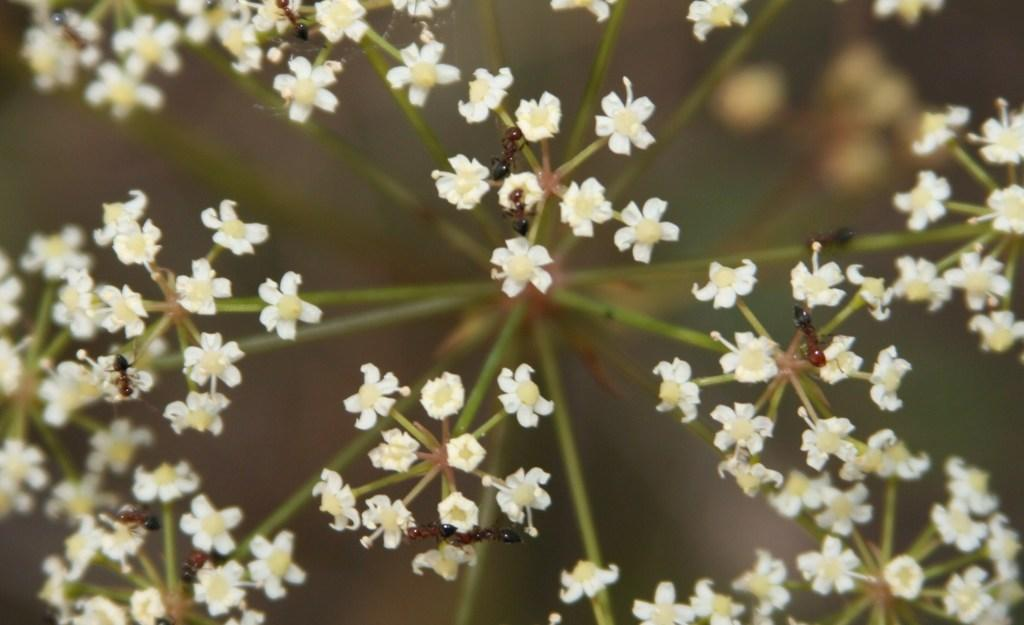What type of flowers can be seen in the image? There are white flowers on the stems in the image. Are there any insects present on the flowers? Yes, there are ants on the flowers. Can you describe the background of the image? The background of the image is blurred. What type of battle is taking place in the image? There is no battle present in the image; it features white flowers with ants on them and a blurred background. Can you see any goats in the image? There are no goats present in the image. 